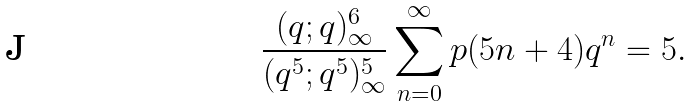<formula> <loc_0><loc_0><loc_500><loc_500>\frac { ( q ; q ) _ { \infty } ^ { 6 } } { ( q ^ { 5 } ; q ^ { 5 } ) _ { \infty } ^ { 5 } } \sum _ { n = 0 } ^ { \infty } p ( 5 n + 4 ) q ^ { n } = 5 .</formula> 